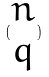Convert formula to latex. <formula><loc_0><loc_0><loc_500><loc_500>( \begin{matrix} n \\ q \end{matrix} )</formula> 